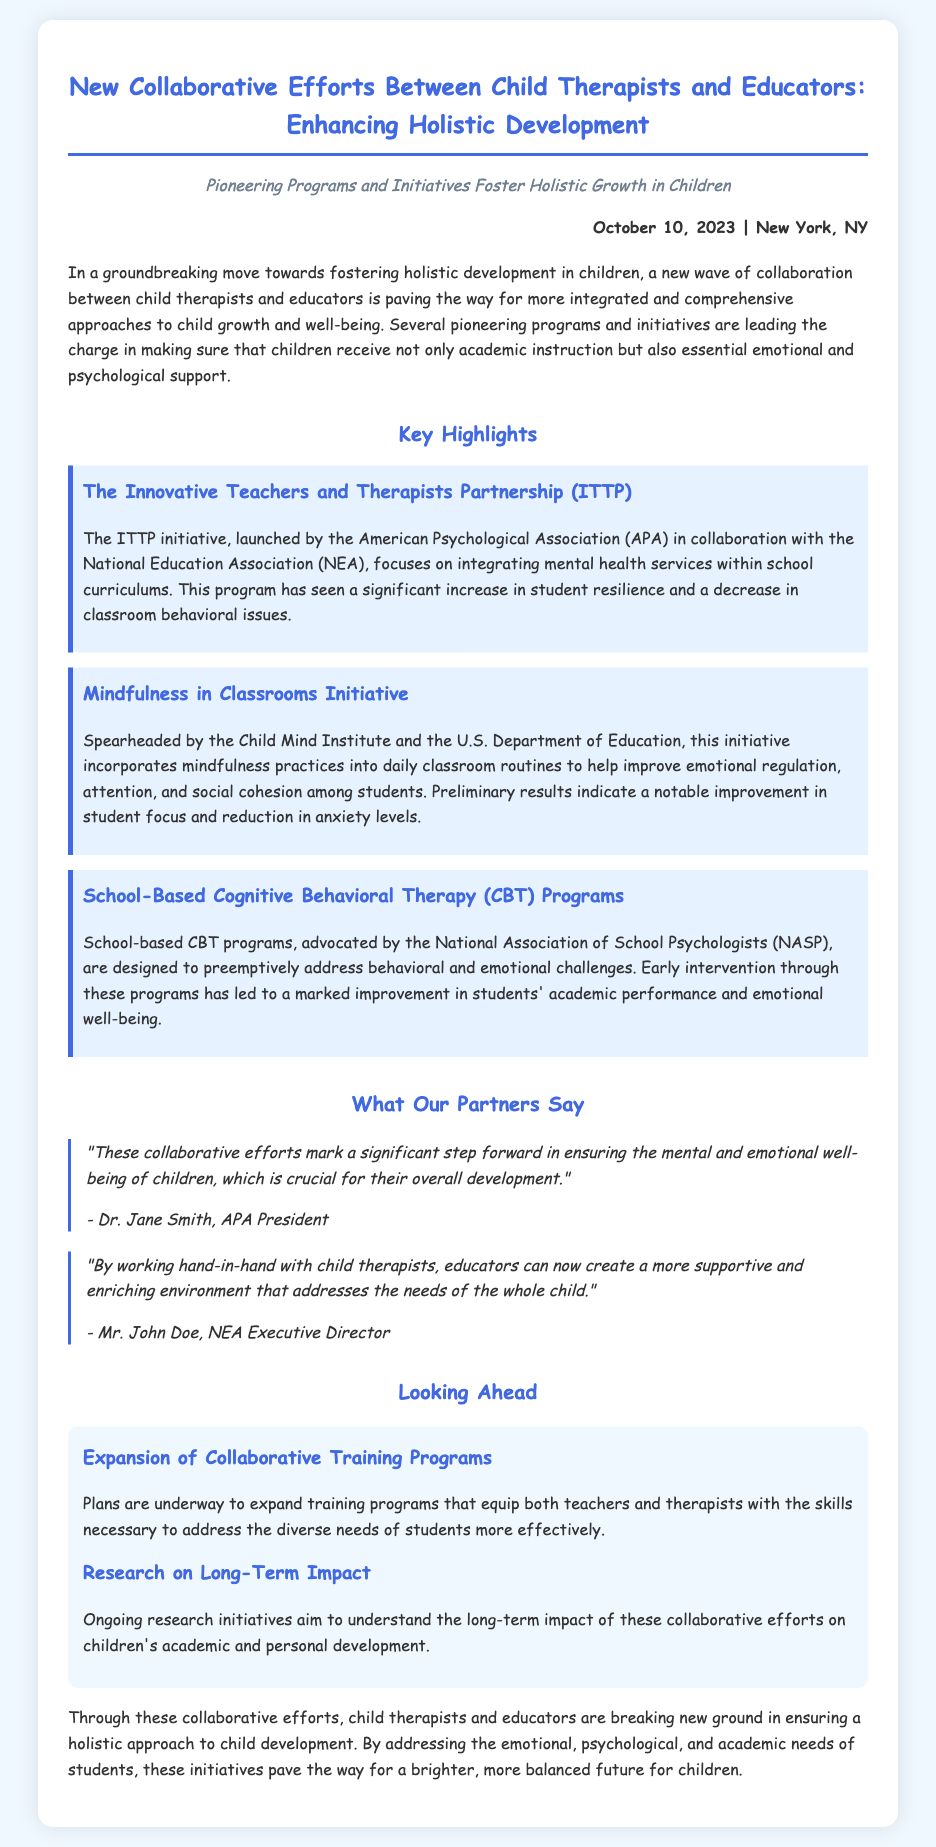What is the title of the press release? The title summarizes the document's focus on collaboration between child therapists and educators.
Answer: New Collaborative Efforts Between Child Therapists and Educators: Enhancing Holistic Development When was the press release issued? The date of publication is mentioned at the top of the document.
Answer: October 10, 2023 What organization launched the ITTP initiative? This information is found in the section discussing the ITTP initiative and its collaborators.
Answer: American Psychological Association (APA) What is one of the main goals of the Mindfulness in Classrooms Initiative? The document states the purpose of this initiative clearly.
Answer: Improve emotional regulation Who is quoted as the APA President in the document? The quote section provides information regarding the speaker.
Answer: Dr. Jane Smith What is a future plan mentioned for these collaborative efforts? The plans outlined indicate the direction for future actions.
Answer: Expansion of Collaborative Training Programs What does CBT stand for in the context of the school-based programs? The abbreviation is defined within the document when discussing these programs.
Answer: Cognitive Behavioral Therapy Which organization collaborates with the Child Mind Institute on mindfulness practices? The collaboration is specified in the details of the initiative.
Answer: U.S. Department of Education What main improvement did school-based CBT programs lead to? The document outlines the outcomes of these programs.
Answer: Improvement in students' academic performance 